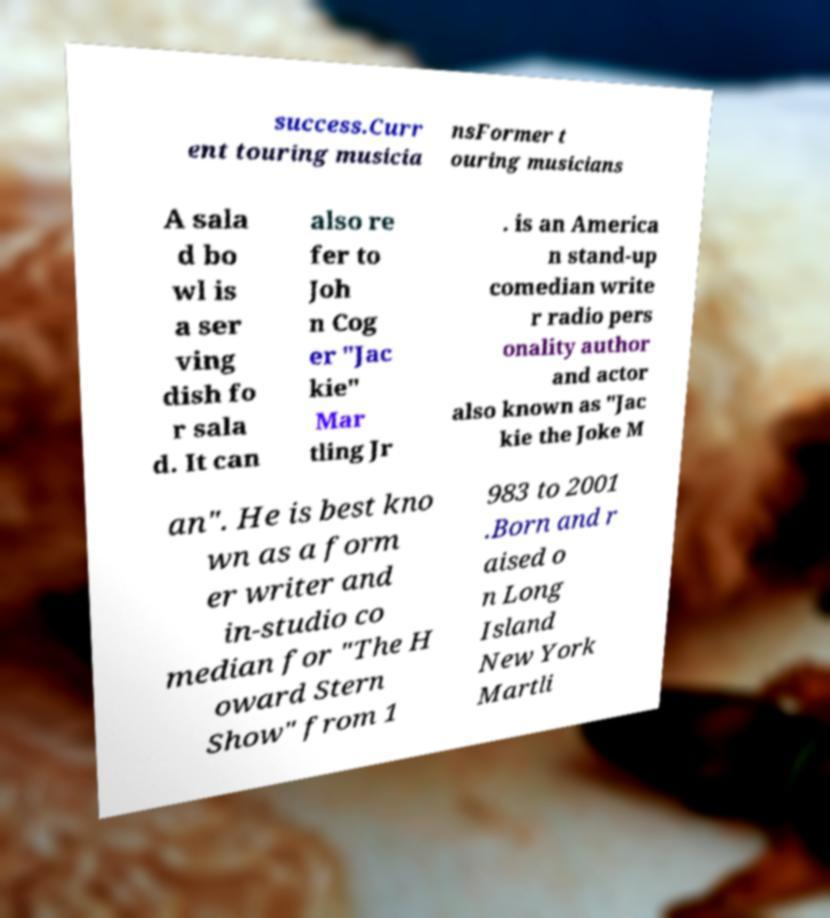What messages or text are displayed in this image? I need them in a readable, typed format. success.Curr ent touring musicia nsFormer t ouring musicians A sala d bo wl is a ser ving dish fo r sala d. It can also re fer to Joh n Cog er "Jac kie" Mar tling Jr . is an America n stand-up comedian write r radio pers onality author and actor also known as "Jac kie the Joke M an". He is best kno wn as a form er writer and in-studio co median for "The H oward Stern Show" from 1 983 to 2001 .Born and r aised o n Long Island New York Martli 